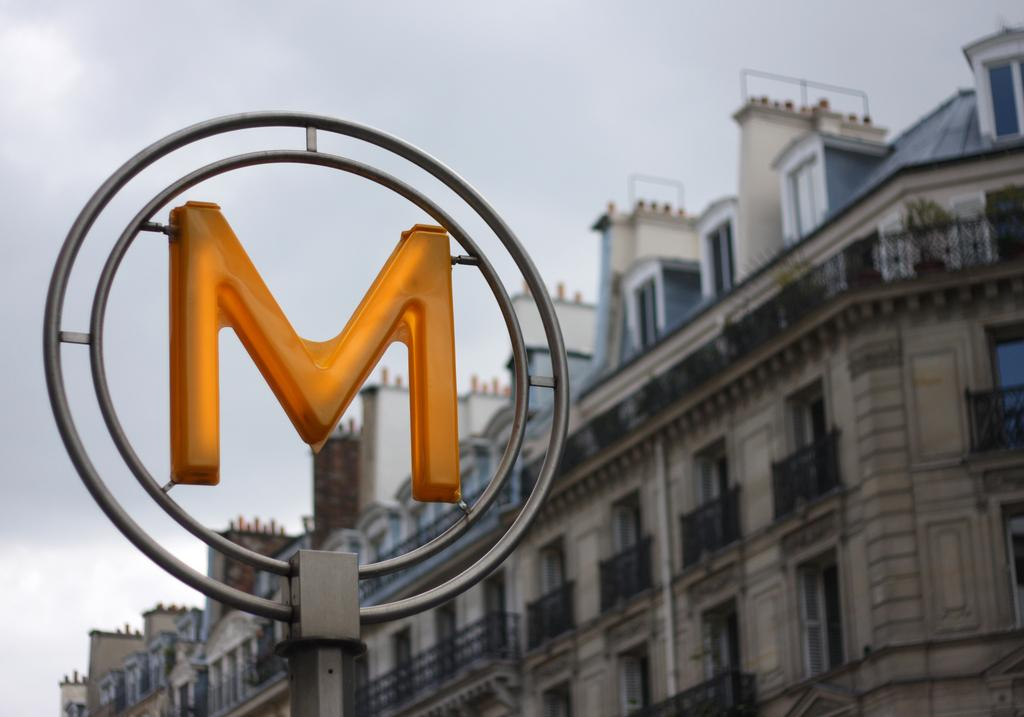What is the main subject of the image? The main subject of the image is an alphabet. How is the alphabet arranged in the image? The alphabet is arranged in two rings in the image. What color is the alphabet in the image? The alphabet is in yellow color in the image. What can be seen in the background of the image? There is a building and the sky visible in the background of the image. What type of disease is affecting the alphabet in the image? There is no indication of any disease affecting the alphabet in the image. The alphabet is simply arranged in two yellow rings. 